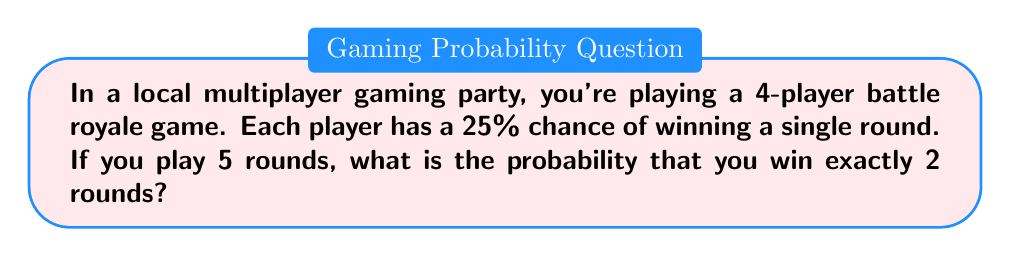Teach me how to tackle this problem. Let's approach this step-by-step:

1) This scenario follows a binomial probability distribution. We need to use the binomial probability formula:

   $$P(X = k) = \binom{n}{k} p^k (1-p)^{n-k}$$

   Where:
   $n$ = number of trials (rounds)
   $k$ = number of successes (wins)
   $p$ = probability of success on each trial

2) In this case:
   $n = 5$ (5 rounds)
   $k = 2$ (we want exactly 2 wins)
   $p = 0.25$ (25% chance of winning each round)

3) Let's substitute these values into the formula:

   $$P(X = 2) = \binom{5}{2} (0.25)^2 (1-0.25)^{5-2}$$

4) Simplify:
   $$P(X = 2) = \binom{5}{2} (0.25)^2 (0.75)^3$$

5) Calculate $\binom{5}{2}$:
   $$\binom{5}{2} = \frac{5!}{2!(5-2)!} = \frac{5 \cdot 4}{2 \cdot 1} = 10$$

6) Substitute this value:
   $$P(X = 2) = 10 \cdot (0.25)^2 \cdot (0.75)^3$$

7) Calculate:
   $$P(X = 2) = 10 \cdot 0.0625 \cdot 0.421875 = 0.263671875$$

8) Convert to a percentage:
   $$0.263671875 \cdot 100\% = 26.37\%$$
Answer: 26.37% 